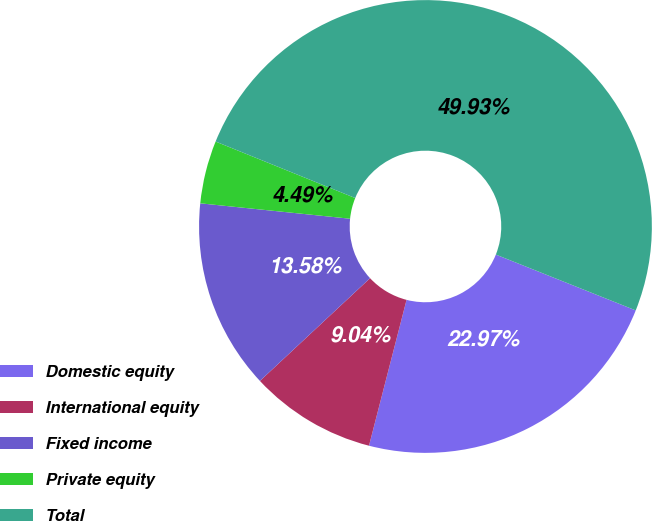Convert chart. <chart><loc_0><loc_0><loc_500><loc_500><pie_chart><fcel>Domestic equity<fcel>International equity<fcel>Fixed income<fcel>Private equity<fcel>Total<nl><fcel>22.97%<fcel>9.04%<fcel>13.58%<fcel>4.49%<fcel>49.93%<nl></chart> 